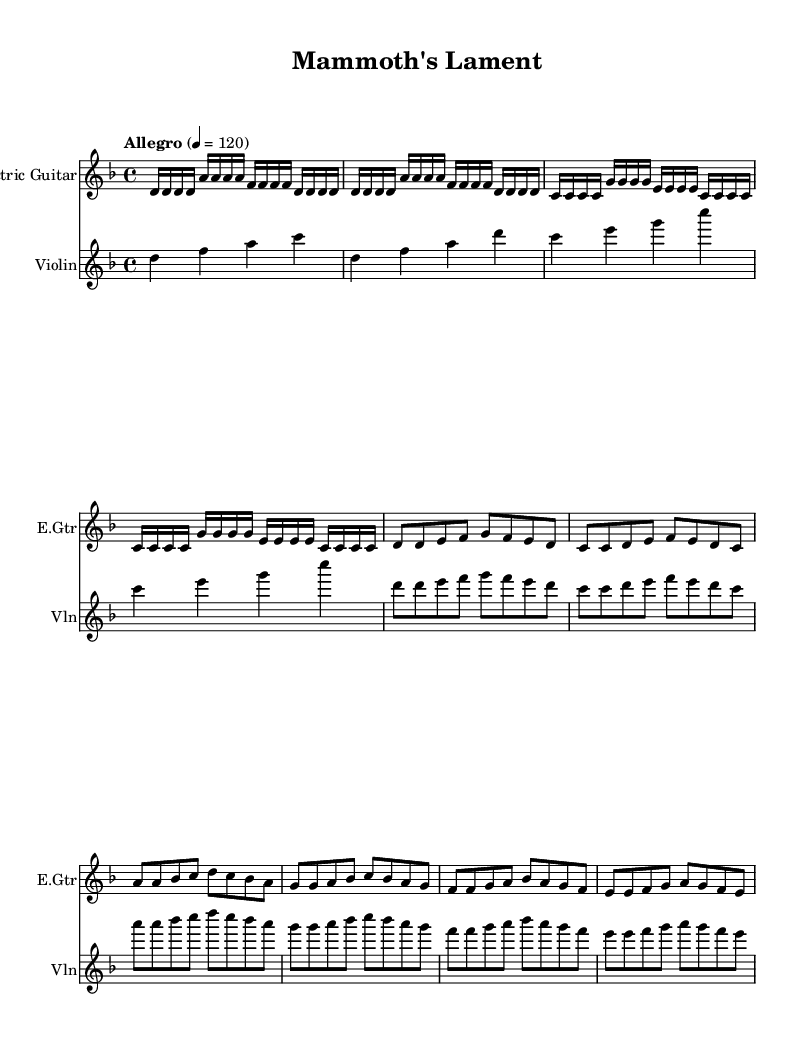What is the key signature of this music? The key signature is indicated at the beginning of the piece. In this case, it shows one flat, which corresponds to the key of D minor.
Answer: D minor What is the time signature of this music? The time signature is indicated at the beginning of the piece, specified by the "4/4" notation. This means there are four beats in each measure, and the quarter note gets one beat.
Answer: 4/4 What is the tempo marking of this piece? The tempo marking is provided at the beginning, stating "Allegro" followed by "4 = 120," indicating the speed of the piece. "120" refers to the beats per minute.
Answer: Allegro, 120 What instruments are featured in the score? The score contains two distinct staves, each labeled with instrument names: "Electric Guitar" and "Violin." This indicates that these are the instruments performing the piece.
Answer: Electric Guitar and Violin How many measures are in the intro section for the electric guitar? By counting the individual sequences of notes in the defined intro section of the electric guitar part, we find that it consists of four full measures.
Answer: 4 Which section of the music is characterized by a faster melodic contour? The Chorus section is located after the Verse and features a rise in pitch and faster note values, creating a more dynamic and intense feel, typical of Metal music.
Answer: Chorus Are there any repeated musical phrases in this score? After examining the structure of the piece, it's clear that the initial musical motif introduced in the Intro is echoed and reprised later in both the Verse and Chorus, indicating a clear use of repetition.
Answer: Yes 